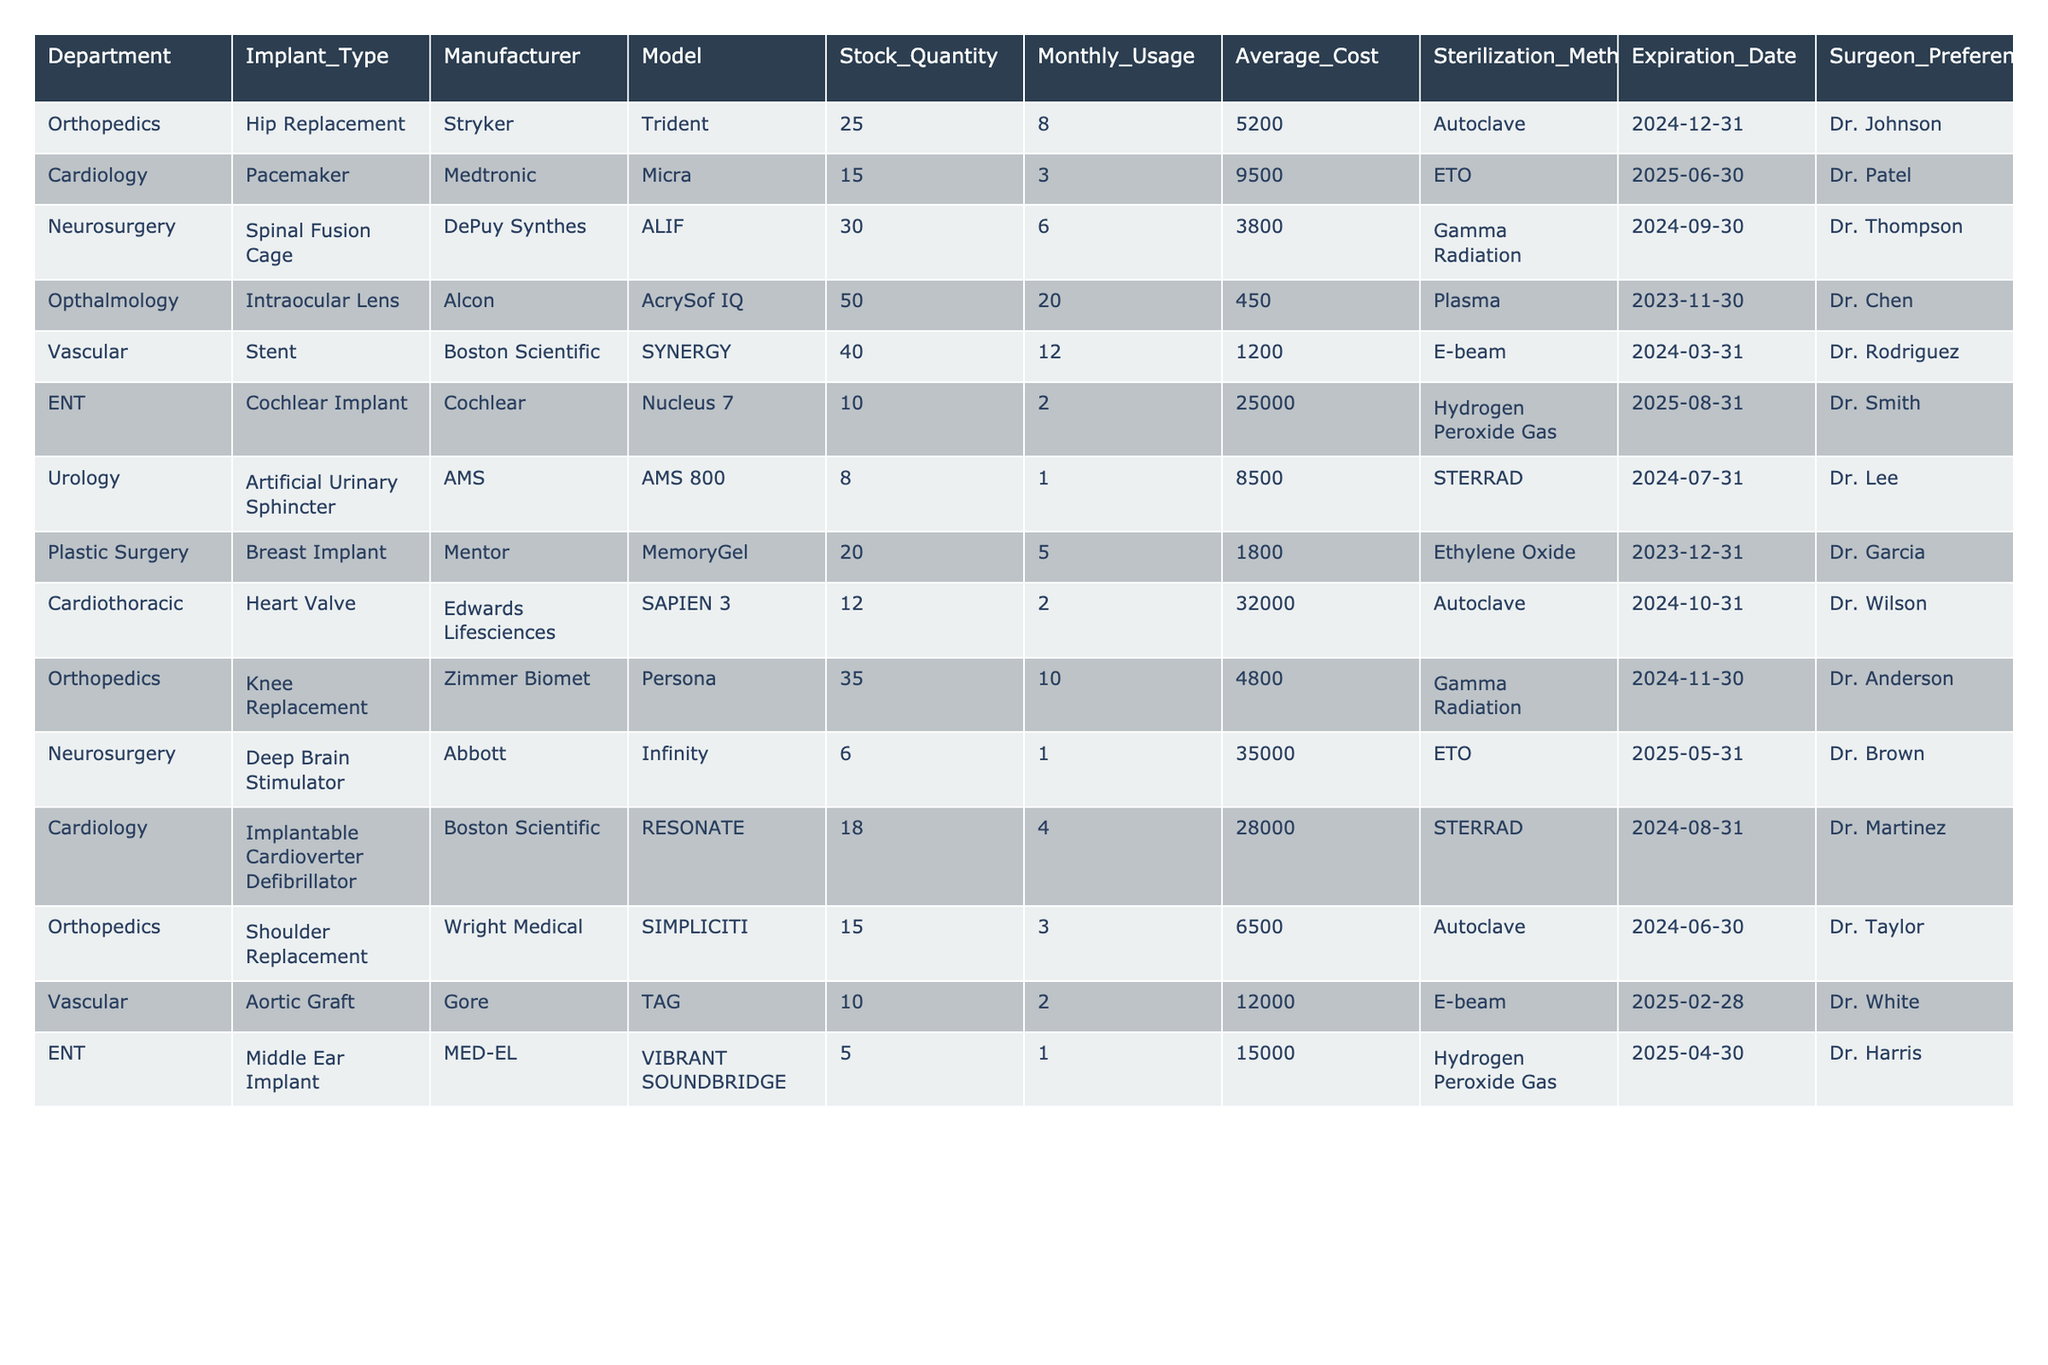What is the stock quantity of the Hip Replacement implant? The table lists the Hip Replacement implant under the Orthopedics department with a stock quantity of 25.
Answer: 25 Which department uses the most costly implant based on average cost? The Cochlear Implant in the ENT department has the highest average cost of 25,000, compared to others.
Answer: ENT department How many total Stents are in stock across hospitals? The stock quantity of Stents under Vascular is 40. So, the total stock of Stents is 40.
Answer: 40 Is there any implant with a stock quantity less than 10? The table shows that only the Deep Brain Stimulator, Aortic Graft, and Cochlear Implant have stock quantities below 10. Thus, the answer is yes.
Answer: Yes What is the average monthly usage of implants across all departments? To find the average, sum the monthly usage (8 + 3 + 6 + 20 + 12 + 2 + 1 + 5 + 2 + 10 + 1 + 4 + 3 + 2 + 1 = 75) and divide by the number of implant types (15). So, 75/15 equals 5.
Answer: 5 Do any surgeons prefer implants with sterilization methods other than Autoclave? Yes, several implants have different sterilization methods including ETO, Gamma Radiation, STERRAD, and Hydrogen Peroxide Gas, while only 4 are Autoclave.
Answer: Yes Which implant type has the highest stock quantity, and what is the quantity? The Intraocular Lens under the Opthalmology department has the highest stock quantity of 50.
Answer: Intraocular Lens, 50 What is the difference in stock quantity between the most used implant and the least used implant? The most used implant is the Intraocular Lens with 20 monthly usages and the least used is the Artificial Urinary Sphincter with 1. Their stock quantities are 50 and 8 respectively, therefore the difference is 50 - 8 = 42.
Answer: 42 Which surgeon has a preference for the Heart Valve implant? The Heart Valve implant is preferred by Dr. Wilson according to the table.
Answer: Dr. Wilson What is the total average cost of implants in the Vascular department? The total average cost for the Stent and Aortic Graft in the Vascular department is calculated by adding their average costs (1,200 + 12,000) and dividing by the number of implants (2), resulting in an average cost of 6,600.
Answer: 6,600 